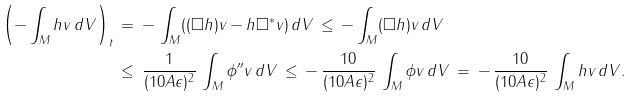Convert formula to latex. <formula><loc_0><loc_0><loc_500><loc_500>\left ( - \int _ { M } h v \, d V \right ) _ { t } \, & = \, - \, \int _ { M } ( ( \square h ) v - h \square ^ { * } v ) \, d V \, \leq \, - \int _ { M } ( \square h ) v \, d V \\ & \leq \, \frac { 1 } { ( 1 0 A \epsilon ) ^ { 2 } } \, \int _ { M } \phi ^ { \prime \prime } v \, d V \, \leq \, - \, \frac { 1 0 } { ( 1 0 A \epsilon ) ^ { 2 } } \, \int _ { M } \phi v \, d V \, = \, - \, \frac { 1 0 } { ( 1 0 A \epsilon ) ^ { 2 } } \, \int _ { M } h v \, d V .</formula> 